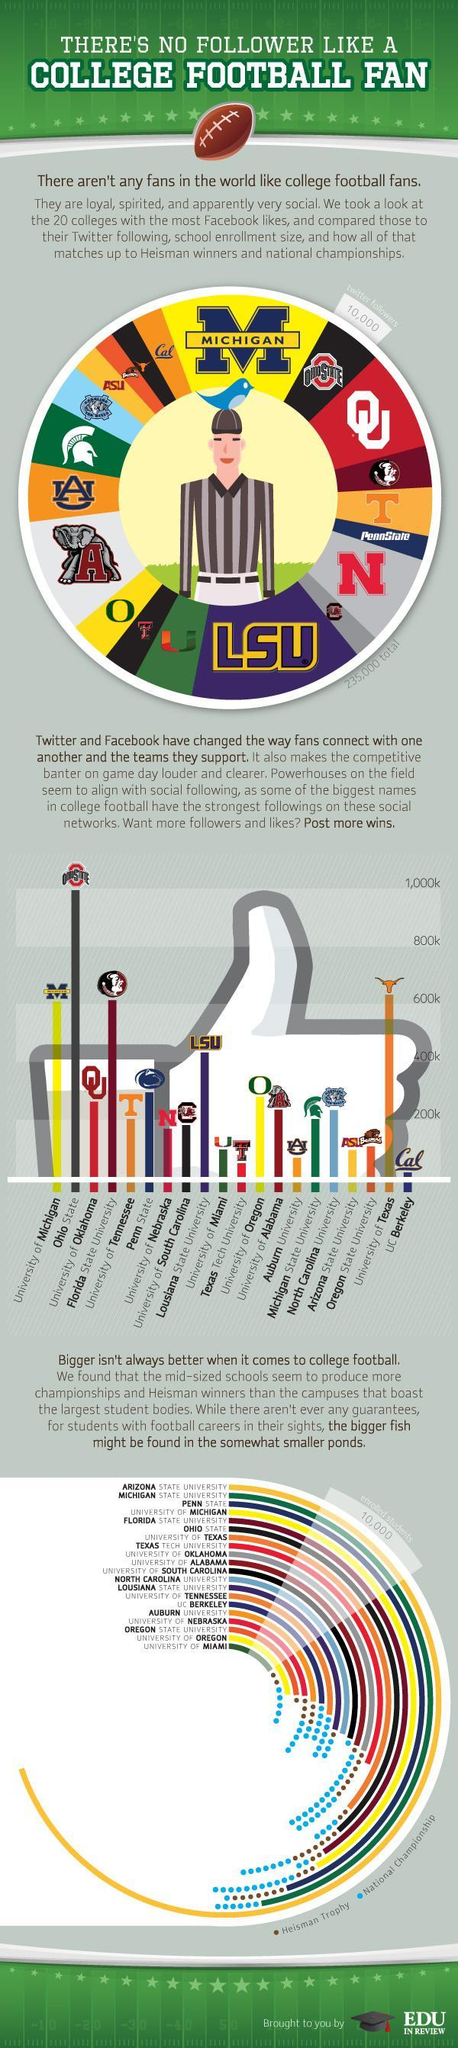How many  Facebook and Twitter likes does University of Oregon have?
Answer the question with a short phrase. 100,000 How many National championships has the largest student body won? 0 Which University has a second smallest student body? University of Oregon Which University has the second largest student body? Michigan State University How many national championships has the University of Miami won? 5 How many Heisman trophies does the largest student body have? 0 How many National championships did the University of Oregon win? 0 Which university is the third largest student body? Penn State What is the colour used to represent National championships in the bar plot - blue, yellow, green or red Blue Which University has the second least number of Facebook and Twitter likes? Texas Tech University What number of students have enrolled in college football from these 20 universities? 10,000 How many National Championships has the smallest student body won? 5 Which University has the second highest number of likes? University of Texas Which University has won the most number of National championships? University of Alabama How many Heisman trophies has University of Miami achieved? 2 Which university has between 400k to 500k likes? Lusiana State University Which three Universities have won 7 Heisman trophies each? Penn State, Ohio State, University Of Oklahoma How many National championships did the Auburn University win? 2 Which three universities have between 600k to 700k likes? University of Michigan, University of Texas, Florida State University 